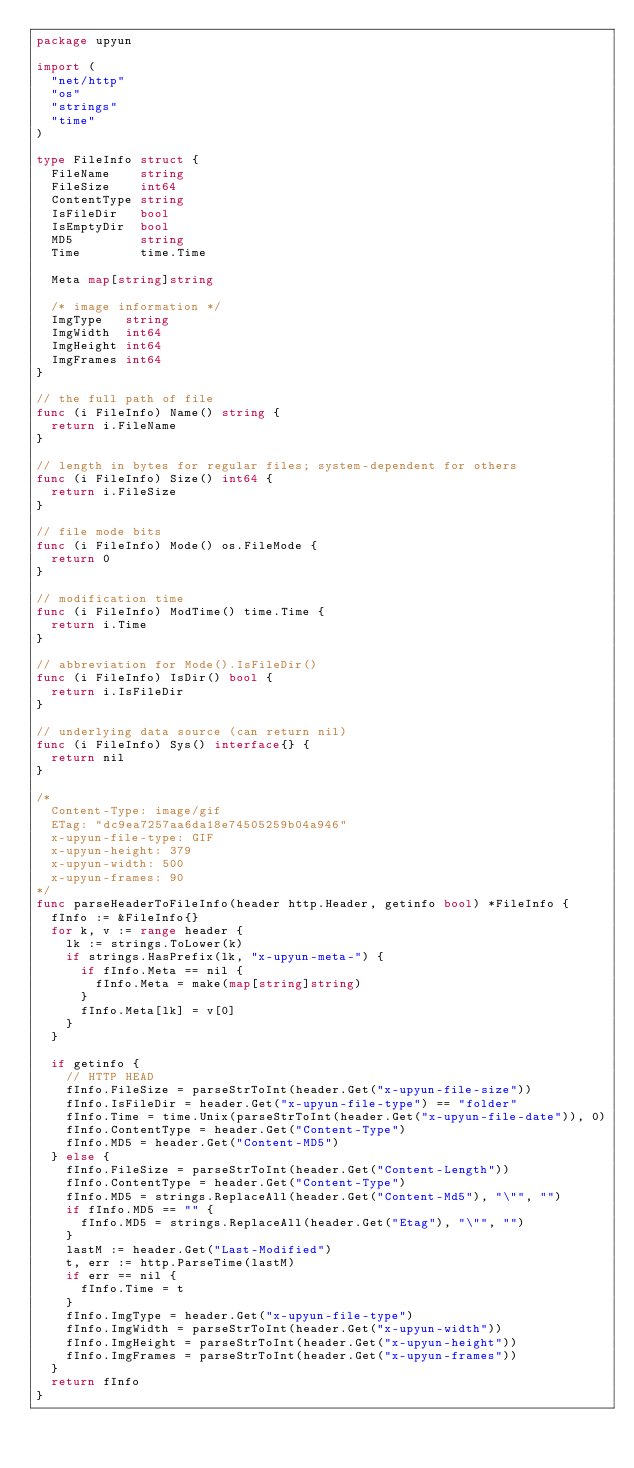<code> <loc_0><loc_0><loc_500><loc_500><_Go_>package upyun

import (
	"net/http"
	"os"
	"strings"
	"time"
)

type FileInfo struct {
	FileName    string
	FileSize    int64
	ContentType string
	IsFileDir   bool
	IsEmptyDir  bool
	MD5         string
	Time        time.Time

	Meta map[string]string

	/* image information */
	ImgType   string
	ImgWidth  int64
	ImgHeight int64
	ImgFrames int64
}

// the full path of file
func (i FileInfo) Name() string {
	return i.FileName
}

// length in bytes for regular files; system-dependent for others
func (i FileInfo) Size() int64 {
	return i.FileSize
}

// file mode bits
func (i FileInfo) Mode() os.FileMode {
	return 0
}

// modification time
func (i FileInfo) ModTime() time.Time {
	return i.Time
}

// abbreviation for Mode().IsFileDir()
func (i FileInfo) IsDir() bool {
	return i.IsFileDir
}

// underlying data source (can return nil)
func (i FileInfo) Sys() interface{} {
	return nil
}

/*
  Content-Type: image/gif
  ETag: "dc9ea7257aa6da18e74505259b04a946"
  x-upyun-file-type: GIF
  x-upyun-height: 379
  x-upyun-width: 500
  x-upyun-frames: 90
*/
func parseHeaderToFileInfo(header http.Header, getinfo bool) *FileInfo {
	fInfo := &FileInfo{}
	for k, v := range header {
		lk := strings.ToLower(k)
		if strings.HasPrefix(lk, "x-upyun-meta-") {
			if fInfo.Meta == nil {
				fInfo.Meta = make(map[string]string)
			}
			fInfo.Meta[lk] = v[0]
		}
	}

	if getinfo {
		// HTTP HEAD
		fInfo.FileSize = parseStrToInt(header.Get("x-upyun-file-size"))
		fInfo.IsFileDir = header.Get("x-upyun-file-type") == "folder"
		fInfo.Time = time.Unix(parseStrToInt(header.Get("x-upyun-file-date")), 0)
		fInfo.ContentType = header.Get("Content-Type")
		fInfo.MD5 = header.Get("Content-MD5")
	} else {
		fInfo.FileSize = parseStrToInt(header.Get("Content-Length"))
		fInfo.ContentType = header.Get("Content-Type")
		fInfo.MD5 = strings.ReplaceAll(header.Get("Content-Md5"), "\"", "")
		if fInfo.MD5 == "" {
			fInfo.MD5 = strings.ReplaceAll(header.Get("Etag"), "\"", "")
		}
		lastM := header.Get("Last-Modified")
		t, err := http.ParseTime(lastM)
		if err == nil {
			fInfo.Time = t
		}
		fInfo.ImgType = header.Get("x-upyun-file-type")
		fInfo.ImgWidth = parseStrToInt(header.Get("x-upyun-width"))
		fInfo.ImgHeight = parseStrToInt(header.Get("x-upyun-height"))
		fInfo.ImgFrames = parseStrToInt(header.Get("x-upyun-frames"))
	}
	return fInfo
}
</code> 